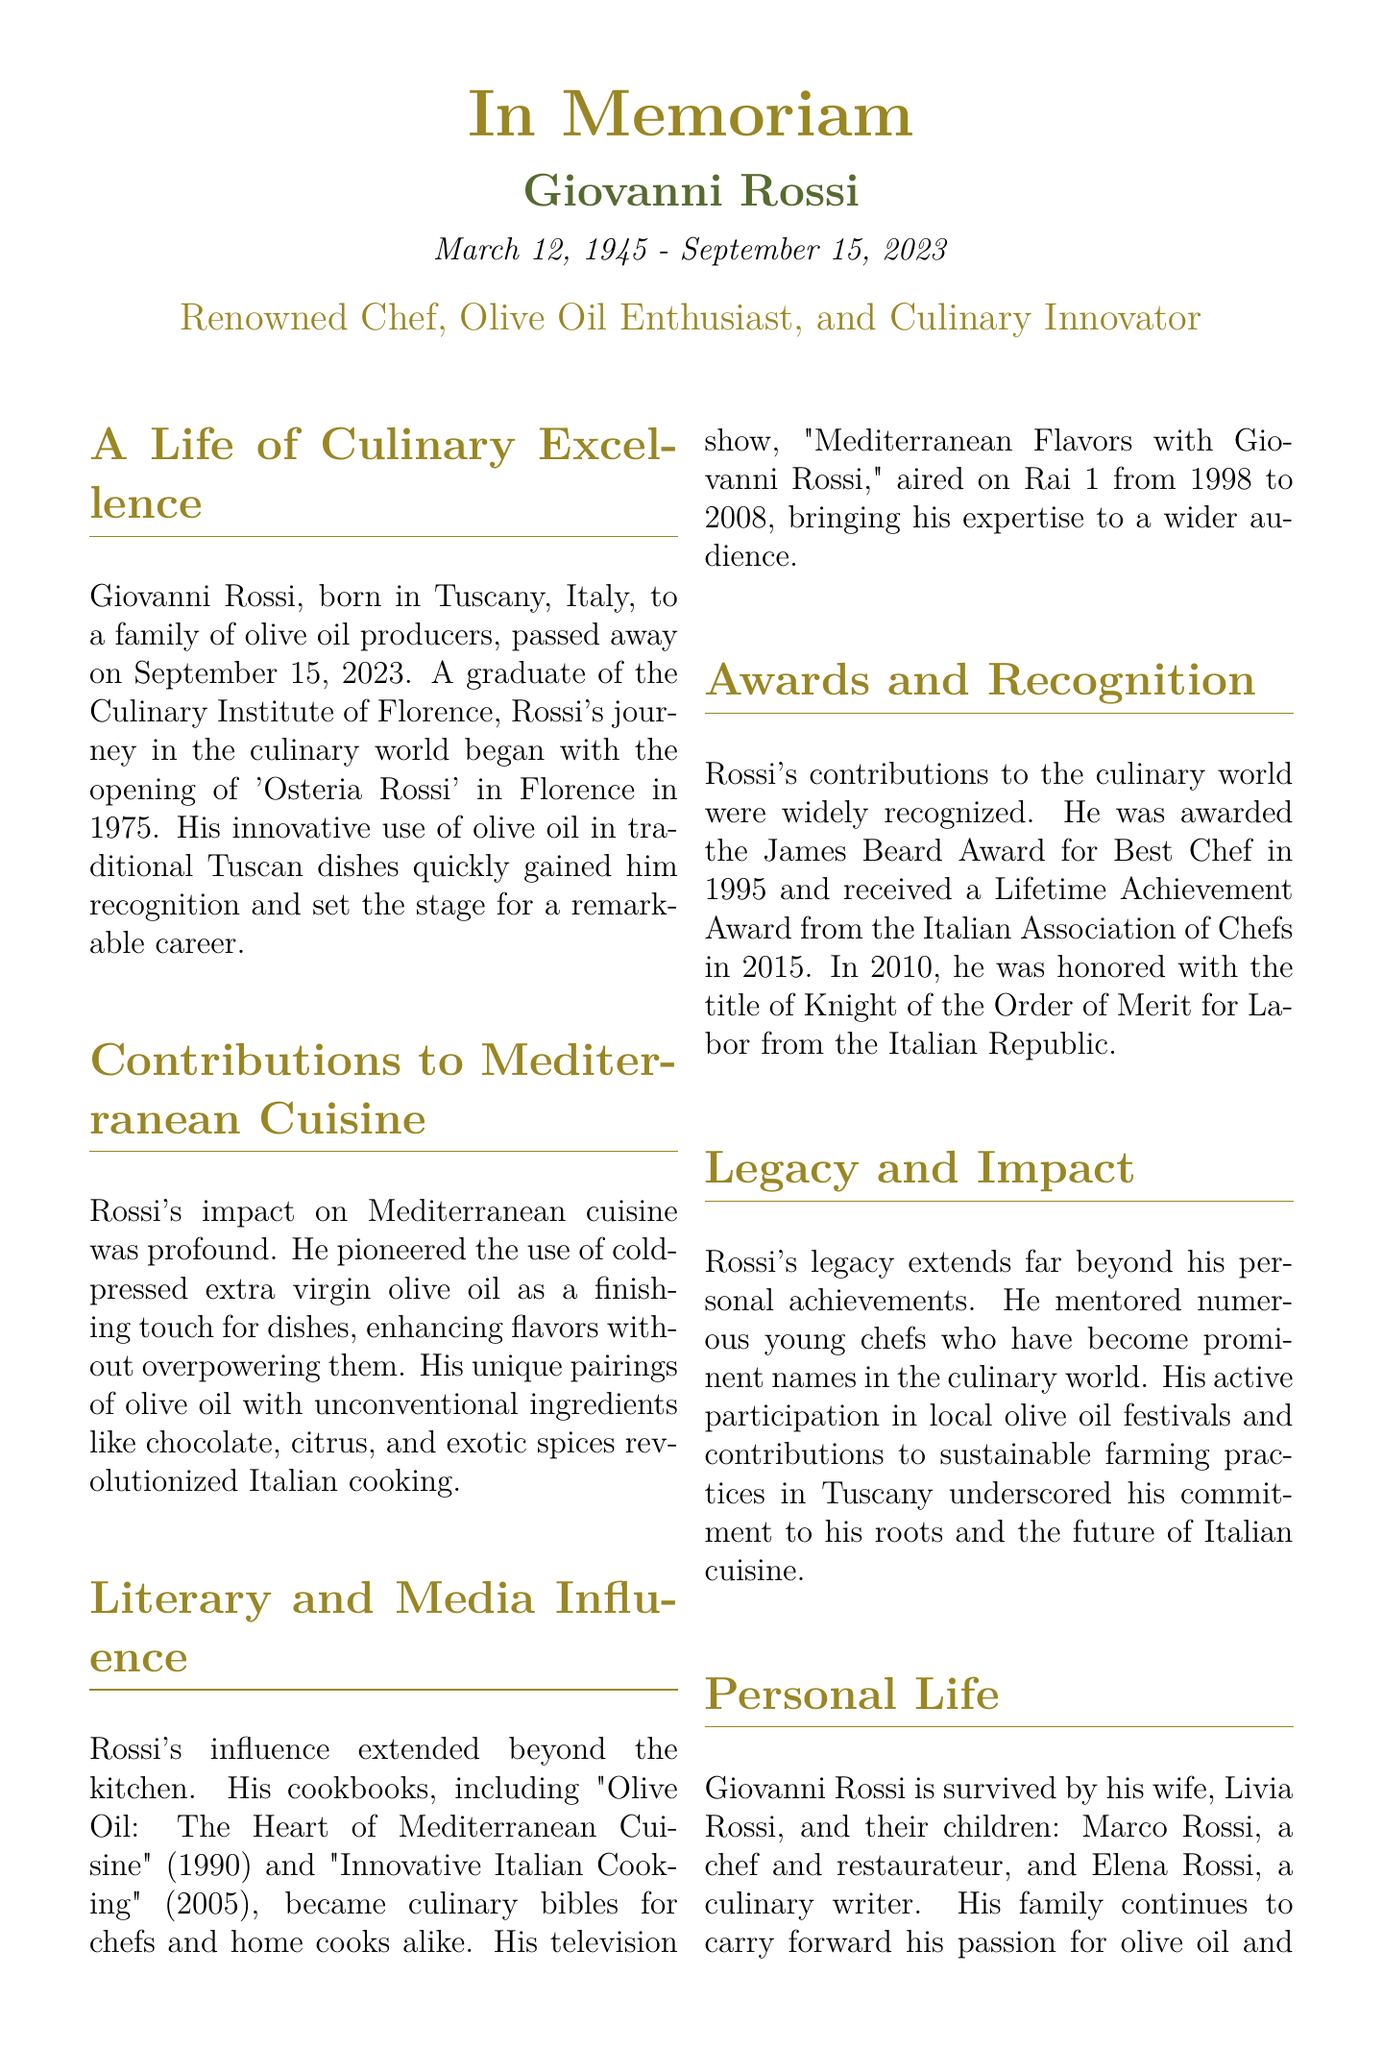What is Giovanni Rossi's birth date? Giovanni Rossi's birth date is mentioned at the beginning of the obituary as March 12, 1945.
Answer: March 12, 1945 What is the title of Giovanni Rossi's first cookbook? The first cookbook mentioned in the obituary is "Olive Oil: The Heart of Mediterranean Cuisine," published in 1990.
Answer: Olive Oil: The Heart of Mediterranean Cuisine Which award did Giovanni Rossi receive in 1995? The obituary states that he was awarded the James Beard Award for Best Chef in 1995.
Answer: James Beard Award for Best Chef What was the name of Giovanni Rossi's television show? The name of his television show is given as "Mediterranean Flavors with Giovanni Rossi," which aired from 1998 to 2008.
Answer: Mediterranean Flavors with Giovanni Rossi Where was Giovanni Rossi born? The document states that he was born in Tuscany, Italy.
Answer: Tuscany, Italy In what year did Giovanni Rossi pass away? The obituary clearly states that Giovanni Rossi passed away on September 15, 2023.
Answer: September 15, 2023 Which culinary practice did Giovanni Rossi advocate for in Tuscany? The document mentions his contributions to sustainable farming practices in Tuscany, highlighting his commitment to the region.
Answer: Sustainable farming practices Who are Giovanni Rossi's immediate survivors? The obituary lists his survivors as his wife, Livia Rossi, and their children, Marco and Elena Rossi.
Answer: Livia Rossi, Marco Rossi, Elena Rossi What was Giovanni Rossi's profession? The document describes Giovanni Rossi primarily as a renowned chef and olive oil enthusiast.
Answer: Chef and olive oil enthusiast 